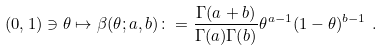<formula> <loc_0><loc_0><loc_500><loc_500>( 0 , 1 ) \ni \theta \mapsto \beta ( \theta ; a , b ) \colon = \frac { \Gamma ( a + b ) } { \Gamma ( a ) \Gamma ( b ) } \theta ^ { a - 1 } ( 1 - \theta ) ^ { b - 1 } \ .</formula> 